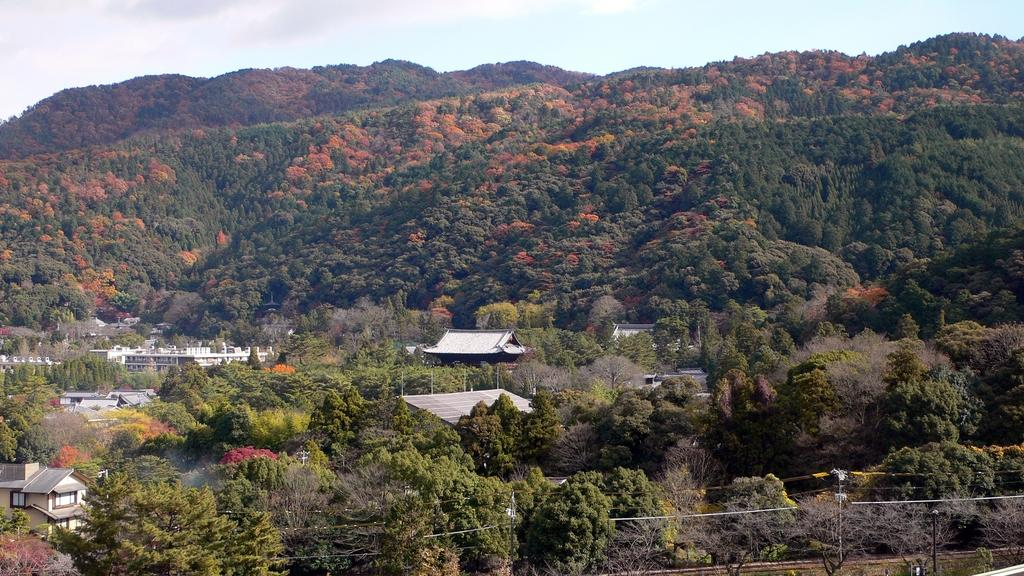What is the main subject in the center of the image? There are houses in the center of the image. What type of natural elements can be seen around the area in the image? There are trees around the area of the image. What objects can be seen at the bottom side of the image? There are poles at the bottom side of the image. What type of stone can be seen forming the mouth of the house in the image? There is no stone or mouth present on the houses in the image. 